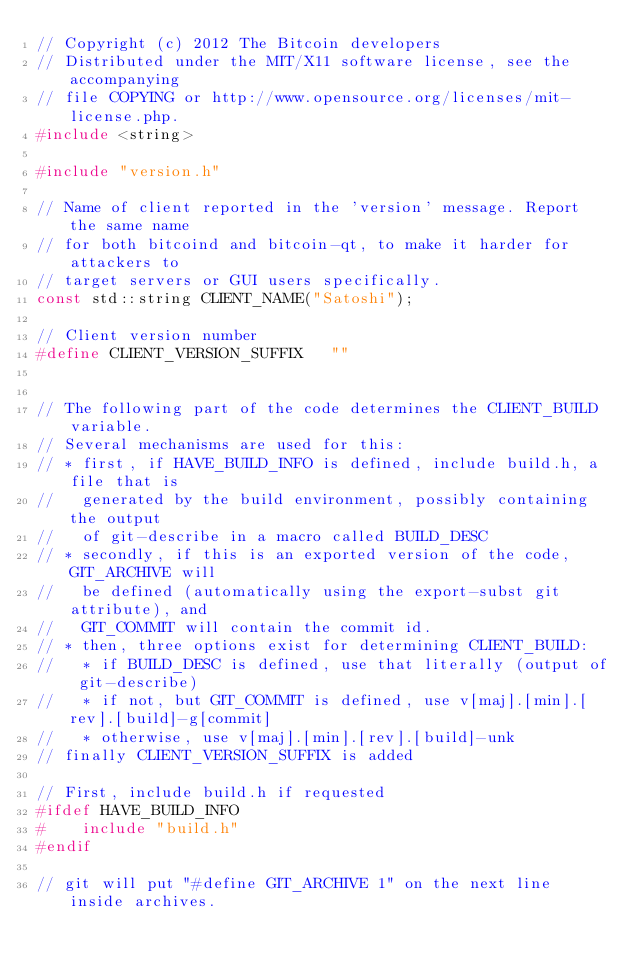<code> <loc_0><loc_0><loc_500><loc_500><_C++_>// Copyright (c) 2012 The Bitcoin developers
// Distributed under the MIT/X11 software license, see the accompanying
// file COPYING or http://www.opensource.org/licenses/mit-license.php.
#include <string>

#include "version.h"

// Name of client reported in the 'version' message. Report the same name
// for both bitcoind and bitcoin-qt, to make it harder for attackers to
// target servers or GUI users specifically.
const std::string CLIENT_NAME("Satoshi");

// Client version number
#define CLIENT_VERSION_SUFFIX   ""


// The following part of the code determines the CLIENT_BUILD variable.
// Several mechanisms are used for this:
// * first, if HAVE_BUILD_INFO is defined, include build.h, a file that is
//   generated by the build environment, possibly containing the output
//   of git-describe in a macro called BUILD_DESC
// * secondly, if this is an exported version of the code, GIT_ARCHIVE will
//   be defined (automatically using the export-subst git attribute), and
//   GIT_COMMIT will contain the commit id.
// * then, three options exist for determining CLIENT_BUILD:
//   * if BUILD_DESC is defined, use that literally (output of git-describe)
//   * if not, but GIT_COMMIT is defined, use v[maj].[min].[rev].[build]-g[commit]
//   * otherwise, use v[maj].[min].[rev].[build]-unk
// finally CLIENT_VERSION_SUFFIX is added

// First, include build.h if requested
#ifdef HAVE_BUILD_INFO
#    include "build.h"
#endif

// git will put "#define GIT_ARCHIVE 1" on the next line inside archives. </code> 